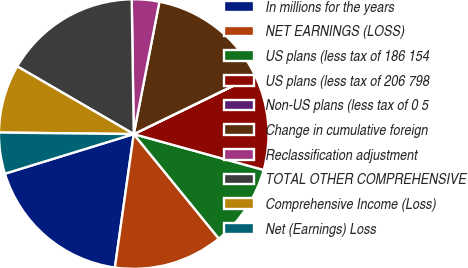<chart> <loc_0><loc_0><loc_500><loc_500><pie_chart><fcel>In millions for the years<fcel>NET EARNINGS (LOSS)<fcel>US plans (less tax of 186 154<fcel>US plans (less tax of 206 798<fcel>Non-US plans (less tax of 0 5<fcel>Change in cumulative foreign<fcel>Reclassification adjustment<fcel>TOTAL OTHER COMPREHENSIVE<fcel>Comprehensive Income (Loss)<fcel>Net (Earnings) Loss<nl><fcel>18.02%<fcel>13.11%<fcel>9.84%<fcel>11.47%<fcel>0.02%<fcel>14.75%<fcel>3.29%<fcel>16.38%<fcel>8.2%<fcel>4.93%<nl></chart> 